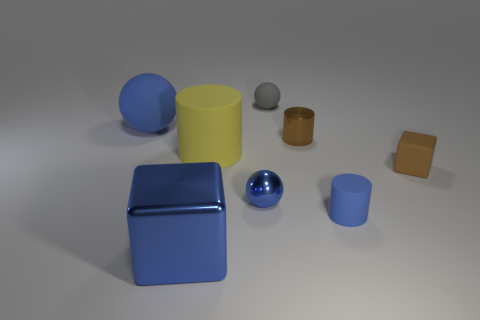Subtract all gray spheres. How many spheres are left? 2 Subtract all small blue balls. How many balls are left? 2 Subtract all balls. How many objects are left? 5 Add 2 large rubber balls. How many objects exist? 10 Subtract 0 purple cylinders. How many objects are left? 8 Subtract 1 cubes. How many cubes are left? 1 Subtract all gray cylinders. Subtract all purple balls. How many cylinders are left? 3 Subtract all green balls. How many cyan cylinders are left? 0 Subtract all cyan metallic blocks. Subtract all big blue cubes. How many objects are left? 7 Add 2 small blue balls. How many small blue balls are left? 3 